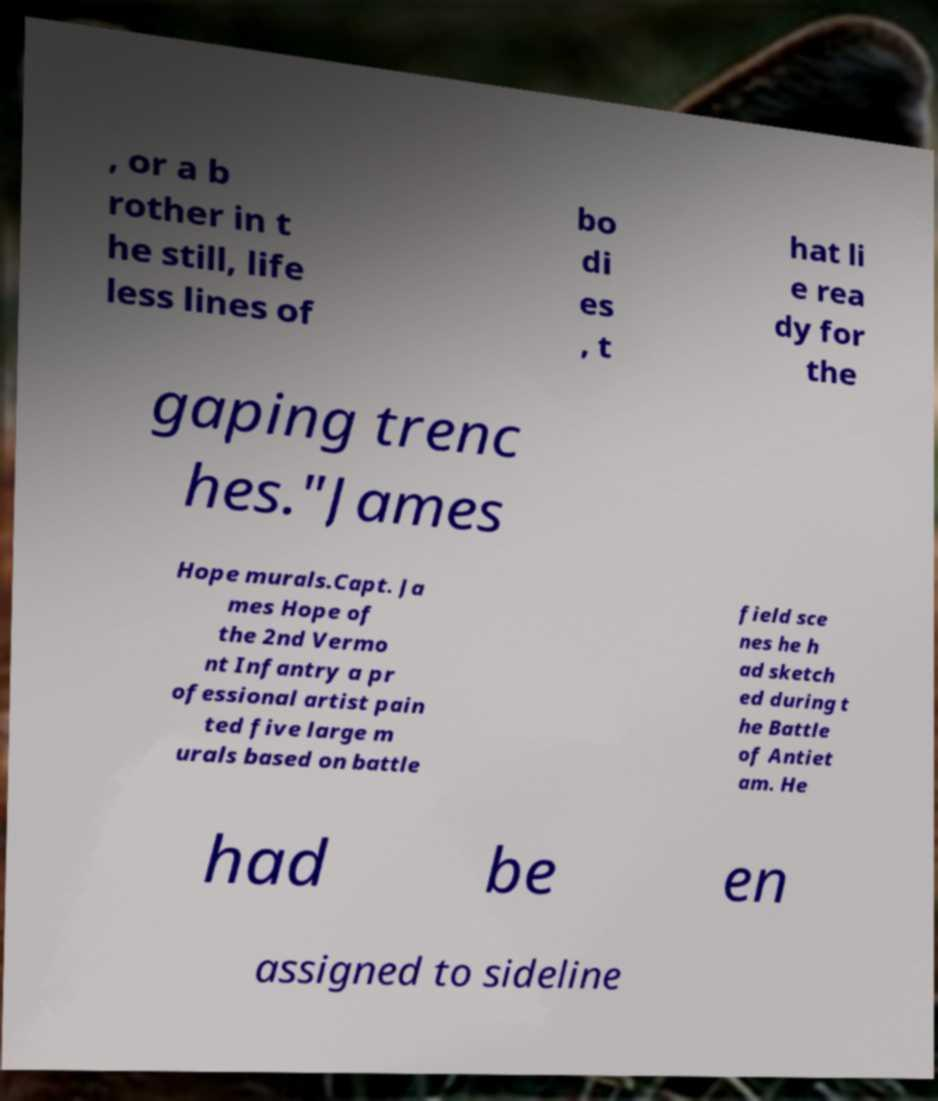Please read and relay the text visible in this image. What does it say? , or a b rother in t he still, life less lines of bo di es , t hat li e rea dy for the gaping trenc hes."James Hope murals.Capt. Ja mes Hope of the 2nd Vermo nt Infantry a pr ofessional artist pain ted five large m urals based on battle field sce nes he h ad sketch ed during t he Battle of Antiet am. He had be en assigned to sideline 